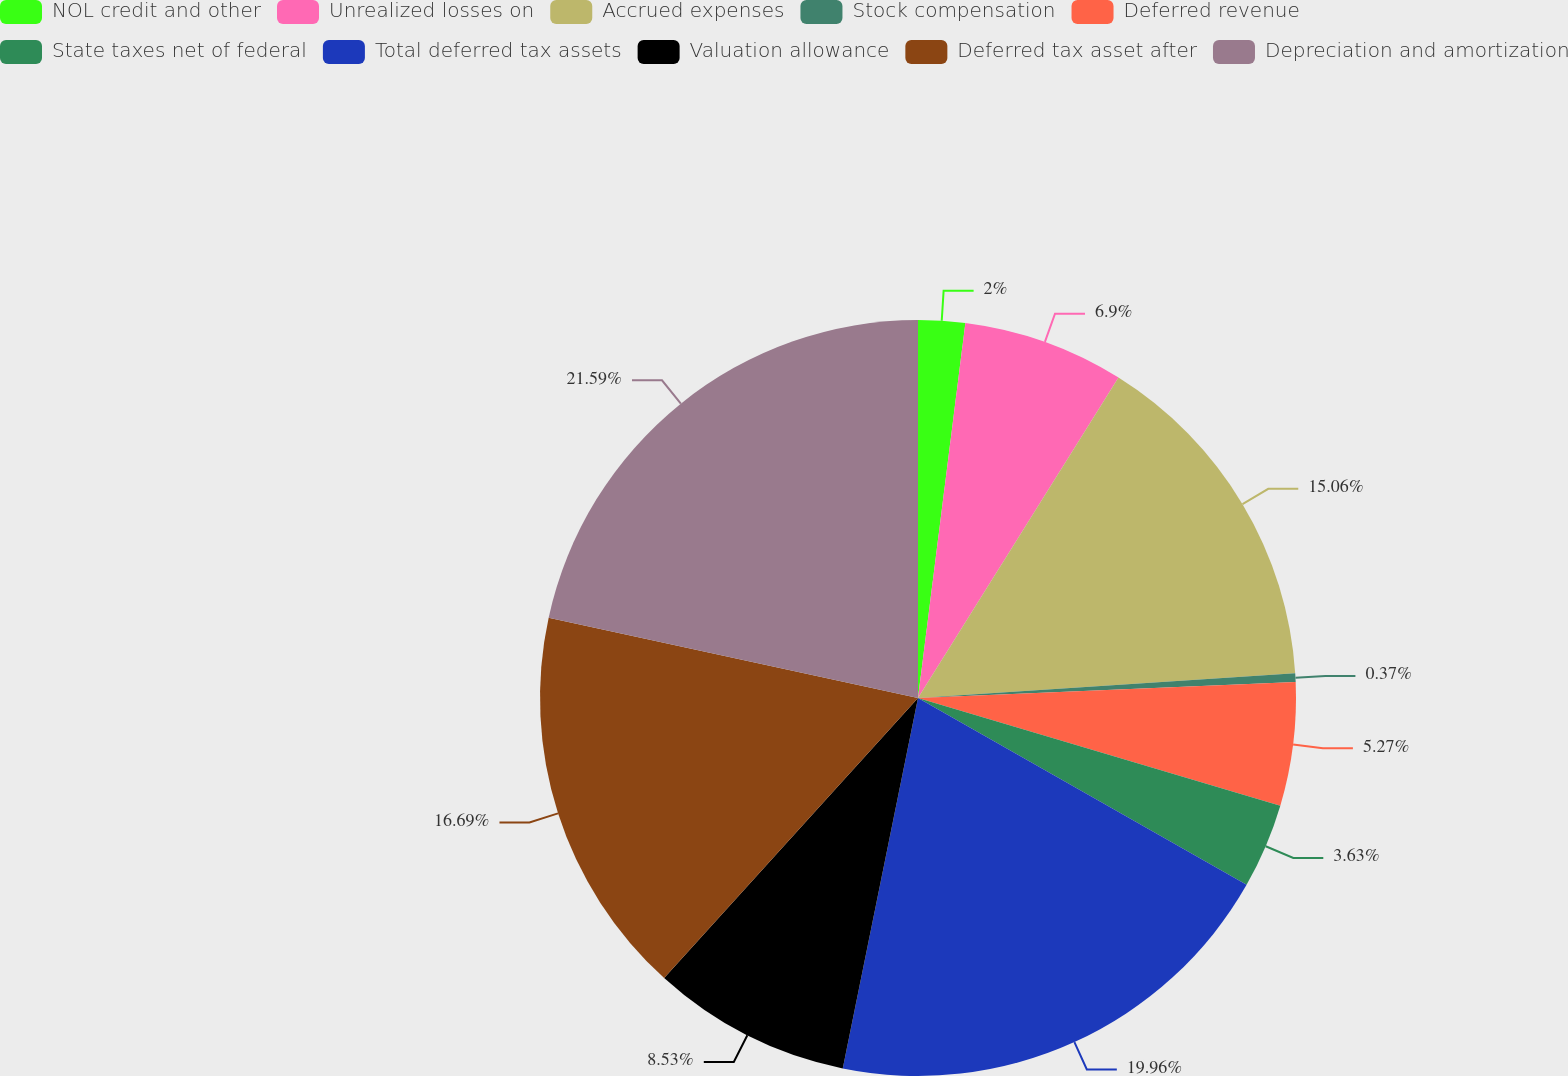Convert chart to OTSL. <chart><loc_0><loc_0><loc_500><loc_500><pie_chart><fcel>NOL credit and other<fcel>Unrealized losses on<fcel>Accrued expenses<fcel>Stock compensation<fcel>Deferred revenue<fcel>State taxes net of federal<fcel>Total deferred tax assets<fcel>Valuation allowance<fcel>Deferred tax asset after<fcel>Depreciation and amortization<nl><fcel>2.0%<fcel>6.9%<fcel>15.06%<fcel>0.37%<fcel>5.27%<fcel>3.63%<fcel>19.96%<fcel>8.53%<fcel>16.69%<fcel>21.59%<nl></chart> 